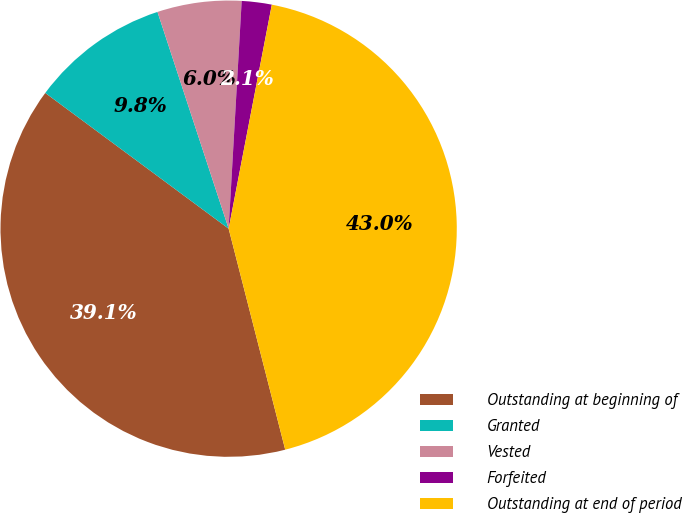Convert chart to OTSL. <chart><loc_0><loc_0><loc_500><loc_500><pie_chart><fcel>Outstanding at beginning of<fcel>Granted<fcel>Vested<fcel>Forfeited<fcel>Outstanding at end of period<nl><fcel>39.13%<fcel>9.81%<fcel>5.96%<fcel>2.12%<fcel>42.98%<nl></chart> 